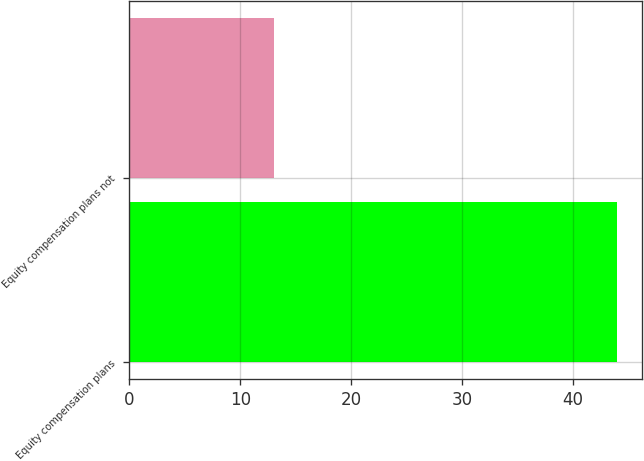<chart> <loc_0><loc_0><loc_500><loc_500><bar_chart><fcel>Equity compensation plans<fcel>Equity compensation plans not<nl><fcel>44<fcel>13<nl></chart> 